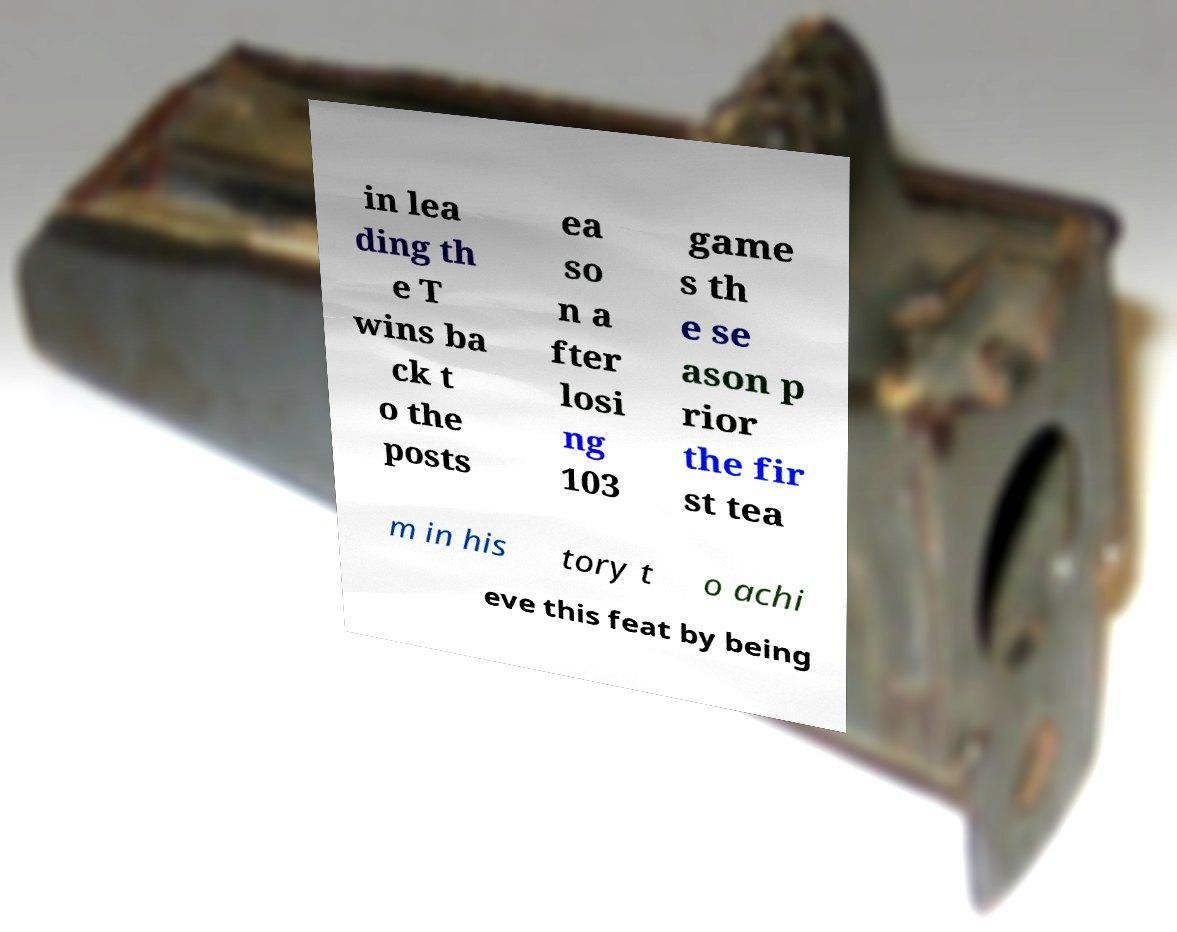Please read and relay the text visible in this image. What does it say? in lea ding th e T wins ba ck t o the posts ea so n a fter losi ng 103 game s th e se ason p rior the fir st tea m in his tory t o achi eve this feat by being 